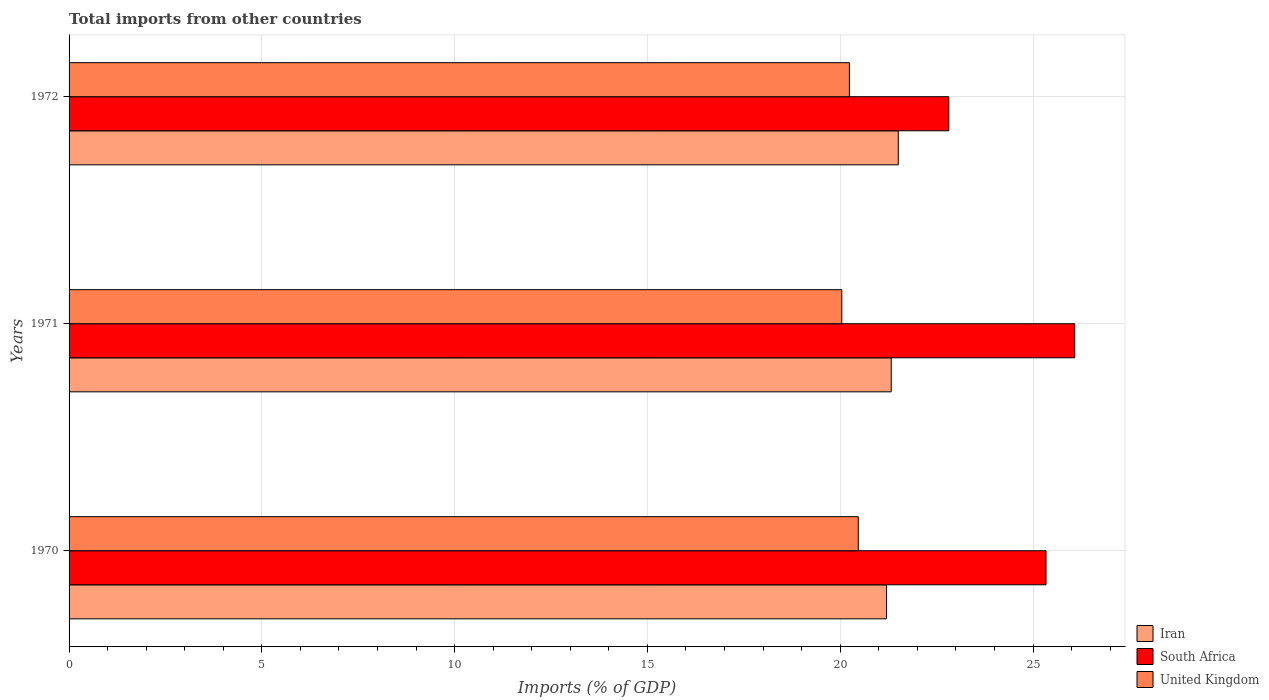How many groups of bars are there?
Keep it short and to the point. 3. Are the number of bars per tick equal to the number of legend labels?
Your response must be concise. Yes. Are the number of bars on each tick of the Y-axis equal?
Your answer should be compact. Yes. How many bars are there on the 2nd tick from the top?
Your response must be concise. 3. How many bars are there on the 3rd tick from the bottom?
Provide a succinct answer. 3. In how many cases, is the number of bars for a given year not equal to the number of legend labels?
Your answer should be very brief. 0. What is the total imports in United Kingdom in 1972?
Offer a very short reply. 20.24. Across all years, what is the maximum total imports in United Kingdom?
Ensure brevity in your answer.  20.47. Across all years, what is the minimum total imports in United Kingdom?
Your answer should be very brief. 20.04. What is the total total imports in United Kingdom in the graph?
Your answer should be very brief. 60.75. What is the difference between the total imports in United Kingdom in 1970 and that in 1971?
Your answer should be very brief. 0.43. What is the difference between the total imports in Iran in 1970 and the total imports in United Kingdom in 1972?
Your answer should be very brief. 0.96. What is the average total imports in Iran per year?
Your response must be concise. 21.34. In the year 1972, what is the difference between the total imports in Iran and total imports in South Africa?
Give a very brief answer. -1.31. In how many years, is the total imports in South Africa greater than 20 %?
Provide a short and direct response. 3. What is the ratio of the total imports in Iran in 1970 to that in 1972?
Keep it short and to the point. 0.99. Is the total imports in South Africa in 1971 less than that in 1972?
Provide a short and direct response. No. What is the difference between the highest and the second highest total imports in South Africa?
Provide a short and direct response. 0.74. What is the difference between the highest and the lowest total imports in South Africa?
Your answer should be very brief. 3.27. Is the sum of the total imports in South Africa in 1970 and 1972 greater than the maximum total imports in Iran across all years?
Offer a terse response. Yes. What does the 2nd bar from the top in 1971 represents?
Ensure brevity in your answer.  South Africa. What does the 3rd bar from the bottom in 1972 represents?
Give a very brief answer. United Kingdom. How many bars are there?
Provide a succinct answer. 9. How many years are there in the graph?
Ensure brevity in your answer.  3. What is the difference between two consecutive major ticks on the X-axis?
Offer a very short reply. 5. Does the graph contain any zero values?
Your answer should be very brief. No. Where does the legend appear in the graph?
Ensure brevity in your answer.  Bottom right. How many legend labels are there?
Ensure brevity in your answer.  3. How are the legend labels stacked?
Your response must be concise. Vertical. What is the title of the graph?
Offer a very short reply. Total imports from other countries. Does "Gambia, The" appear as one of the legend labels in the graph?
Your response must be concise. No. What is the label or title of the X-axis?
Keep it short and to the point. Imports (% of GDP). What is the Imports (% of GDP) of Iran in 1970?
Offer a very short reply. 21.2. What is the Imports (% of GDP) of South Africa in 1970?
Your answer should be compact. 25.34. What is the Imports (% of GDP) of United Kingdom in 1970?
Offer a very short reply. 20.47. What is the Imports (% of GDP) in Iran in 1971?
Make the answer very short. 21.32. What is the Imports (% of GDP) in South Africa in 1971?
Provide a succinct answer. 26.08. What is the Imports (% of GDP) in United Kingdom in 1971?
Your answer should be very brief. 20.04. What is the Imports (% of GDP) in Iran in 1972?
Offer a very short reply. 21.51. What is the Imports (% of GDP) of South Africa in 1972?
Give a very brief answer. 22.82. What is the Imports (% of GDP) of United Kingdom in 1972?
Provide a succinct answer. 20.24. Across all years, what is the maximum Imports (% of GDP) of Iran?
Provide a succinct answer. 21.51. Across all years, what is the maximum Imports (% of GDP) in South Africa?
Offer a very short reply. 26.08. Across all years, what is the maximum Imports (% of GDP) of United Kingdom?
Provide a short and direct response. 20.47. Across all years, what is the minimum Imports (% of GDP) of Iran?
Provide a short and direct response. 21.2. Across all years, what is the minimum Imports (% of GDP) in South Africa?
Offer a terse response. 22.82. Across all years, what is the minimum Imports (% of GDP) in United Kingdom?
Provide a short and direct response. 20.04. What is the total Imports (% of GDP) in Iran in the graph?
Provide a succinct answer. 64.03. What is the total Imports (% of GDP) of South Africa in the graph?
Provide a succinct answer. 74.24. What is the total Imports (% of GDP) of United Kingdom in the graph?
Provide a succinct answer. 60.75. What is the difference between the Imports (% of GDP) in Iran in 1970 and that in 1971?
Ensure brevity in your answer.  -0.12. What is the difference between the Imports (% of GDP) of South Africa in 1970 and that in 1971?
Give a very brief answer. -0.74. What is the difference between the Imports (% of GDP) of United Kingdom in 1970 and that in 1971?
Your answer should be very brief. 0.43. What is the difference between the Imports (% of GDP) of Iran in 1970 and that in 1972?
Ensure brevity in your answer.  -0.3. What is the difference between the Imports (% of GDP) of South Africa in 1970 and that in 1972?
Offer a terse response. 2.52. What is the difference between the Imports (% of GDP) in United Kingdom in 1970 and that in 1972?
Ensure brevity in your answer.  0.23. What is the difference between the Imports (% of GDP) of Iran in 1971 and that in 1972?
Ensure brevity in your answer.  -0.18. What is the difference between the Imports (% of GDP) in South Africa in 1971 and that in 1972?
Give a very brief answer. 3.27. What is the difference between the Imports (% of GDP) of United Kingdom in 1971 and that in 1972?
Keep it short and to the point. -0.2. What is the difference between the Imports (% of GDP) of Iran in 1970 and the Imports (% of GDP) of South Africa in 1971?
Make the answer very short. -4.88. What is the difference between the Imports (% of GDP) in Iran in 1970 and the Imports (% of GDP) in United Kingdom in 1971?
Your response must be concise. 1.16. What is the difference between the Imports (% of GDP) of South Africa in 1970 and the Imports (% of GDP) of United Kingdom in 1971?
Your answer should be very brief. 5.3. What is the difference between the Imports (% of GDP) in Iran in 1970 and the Imports (% of GDP) in South Africa in 1972?
Keep it short and to the point. -1.62. What is the difference between the Imports (% of GDP) of Iran in 1970 and the Imports (% of GDP) of United Kingdom in 1972?
Keep it short and to the point. 0.96. What is the difference between the Imports (% of GDP) of South Africa in 1970 and the Imports (% of GDP) of United Kingdom in 1972?
Offer a very short reply. 5.1. What is the difference between the Imports (% of GDP) of Iran in 1971 and the Imports (% of GDP) of South Africa in 1972?
Your response must be concise. -1.49. What is the difference between the Imports (% of GDP) of Iran in 1971 and the Imports (% of GDP) of United Kingdom in 1972?
Provide a short and direct response. 1.08. What is the difference between the Imports (% of GDP) of South Africa in 1971 and the Imports (% of GDP) of United Kingdom in 1972?
Make the answer very short. 5.84. What is the average Imports (% of GDP) of Iran per year?
Your response must be concise. 21.34. What is the average Imports (% of GDP) of South Africa per year?
Provide a succinct answer. 24.75. What is the average Imports (% of GDP) in United Kingdom per year?
Your response must be concise. 20.25. In the year 1970, what is the difference between the Imports (% of GDP) in Iran and Imports (% of GDP) in South Africa?
Offer a terse response. -4.14. In the year 1970, what is the difference between the Imports (% of GDP) of Iran and Imports (% of GDP) of United Kingdom?
Offer a very short reply. 0.73. In the year 1970, what is the difference between the Imports (% of GDP) of South Africa and Imports (% of GDP) of United Kingdom?
Offer a very short reply. 4.87. In the year 1971, what is the difference between the Imports (% of GDP) of Iran and Imports (% of GDP) of South Africa?
Offer a very short reply. -4.76. In the year 1971, what is the difference between the Imports (% of GDP) in Iran and Imports (% of GDP) in United Kingdom?
Your answer should be compact. 1.28. In the year 1971, what is the difference between the Imports (% of GDP) in South Africa and Imports (% of GDP) in United Kingdom?
Provide a short and direct response. 6.04. In the year 1972, what is the difference between the Imports (% of GDP) of Iran and Imports (% of GDP) of South Africa?
Offer a terse response. -1.31. In the year 1972, what is the difference between the Imports (% of GDP) of Iran and Imports (% of GDP) of United Kingdom?
Provide a short and direct response. 1.27. In the year 1972, what is the difference between the Imports (% of GDP) of South Africa and Imports (% of GDP) of United Kingdom?
Your response must be concise. 2.58. What is the ratio of the Imports (% of GDP) in Iran in 1970 to that in 1971?
Make the answer very short. 0.99. What is the ratio of the Imports (% of GDP) of South Africa in 1970 to that in 1971?
Your response must be concise. 0.97. What is the ratio of the Imports (% of GDP) of United Kingdom in 1970 to that in 1971?
Keep it short and to the point. 1.02. What is the ratio of the Imports (% of GDP) of Iran in 1970 to that in 1972?
Your answer should be very brief. 0.99. What is the ratio of the Imports (% of GDP) in South Africa in 1970 to that in 1972?
Your answer should be compact. 1.11. What is the ratio of the Imports (% of GDP) in United Kingdom in 1970 to that in 1972?
Ensure brevity in your answer.  1.01. What is the ratio of the Imports (% of GDP) in South Africa in 1971 to that in 1972?
Offer a terse response. 1.14. What is the ratio of the Imports (% of GDP) of United Kingdom in 1971 to that in 1972?
Your response must be concise. 0.99. What is the difference between the highest and the second highest Imports (% of GDP) in Iran?
Provide a short and direct response. 0.18. What is the difference between the highest and the second highest Imports (% of GDP) of South Africa?
Provide a succinct answer. 0.74. What is the difference between the highest and the second highest Imports (% of GDP) in United Kingdom?
Provide a short and direct response. 0.23. What is the difference between the highest and the lowest Imports (% of GDP) of Iran?
Make the answer very short. 0.3. What is the difference between the highest and the lowest Imports (% of GDP) in South Africa?
Give a very brief answer. 3.27. What is the difference between the highest and the lowest Imports (% of GDP) of United Kingdom?
Give a very brief answer. 0.43. 